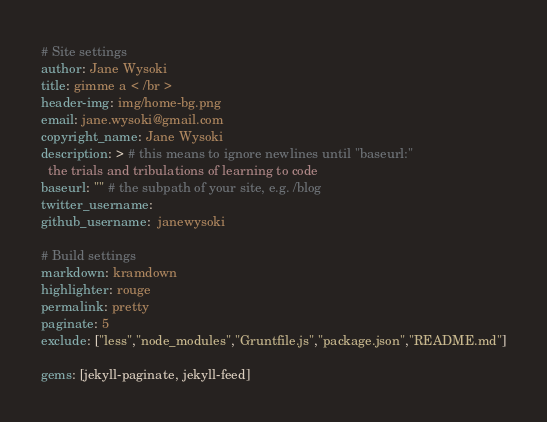<code> <loc_0><loc_0><loc_500><loc_500><_YAML_># Site settings
author: Jane Wysoki
title: gimme a < /br >
header-img: img/home-bg.png
email: jane.wysoki@gmail.com
copyright_name: Jane Wysoki
description: > # this means to ignore newlines until "baseurl:"
  the trials and tribulations of learning to code
baseurl: "" # the subpath of your site, e.g. /blog
twitter_username: 
github_username:  janewysoki

# Build settings
markdown: kramdown
highlighter: rouge
permalink: pretty
paginate: 5
exclude: ["less","node_modules","Gruntfile.js","package.json","README.md"]

gems: [jekyll-paginate, jekyll-feed]
</code> 